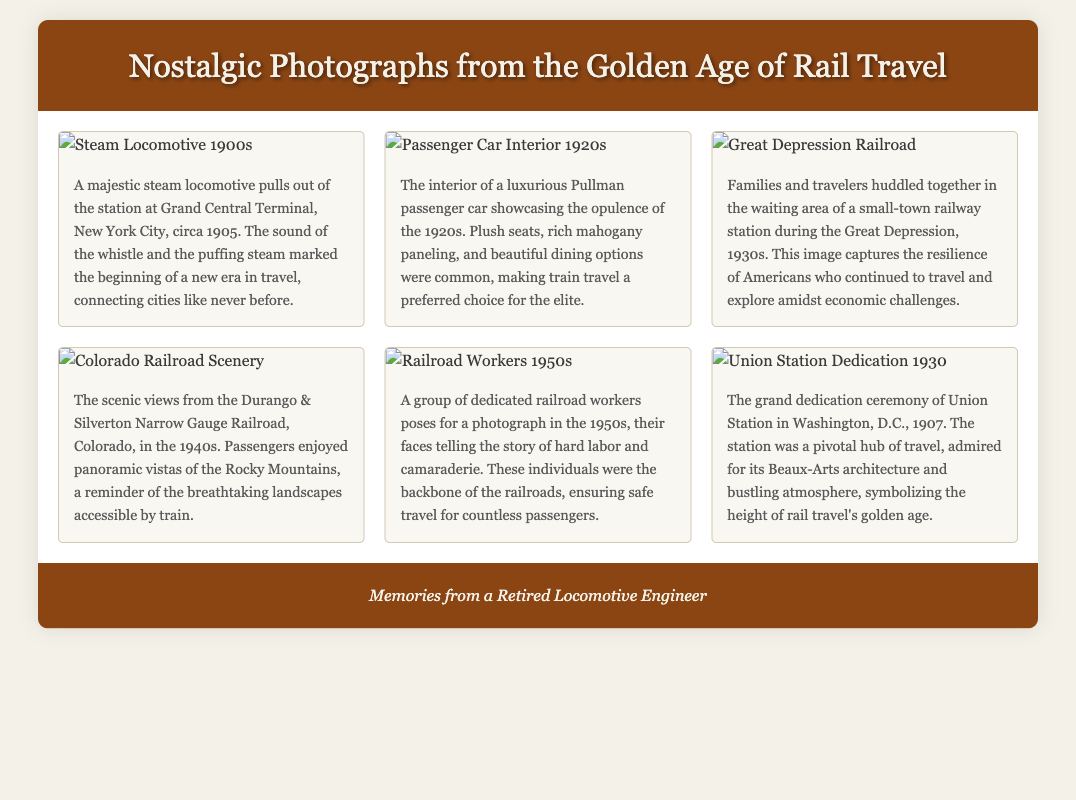What year was the steam locomotive photograph taken? The caption for the steam locomotive photograph specifies it was taken circa 1905.
Answer: 1905 What kind of passenger car is described in the 1920s photograph? The caption describes the passenger car as a luxurious Pullman passenger car.
Answer: Pullman What economic period is depicted in the photograph of the railway station? The caption mentions that the photograph shows a waiting area during the Great Depression.
Answer: Great Depression In which state did the Durango & Silverton Narrow Gauge Railroad operate? The caption notes that the scenic views were from Colorado.
Answer: Colorado What architectural style is mentioned regarding Union Station? The caption describes Union Station as being admired for its Beaux-Arts architecture.
Answer: Beaux-Arts What decade is represented by the photograph of railroad workers? The caption specifies that the photograph of railroad workers was taken in the 1950s.
Answer: 1950s What is emphasized about the railroad workers' role in the caption? The caption highlights that the railroad workers were the backbone of the railroads.
Answer: Backbone What was a key attraction of train travel according to the 1940s photograph? The caption mentions breathtaking landscapes were a key attraction of train travel.
Answer: Breathtaking landscapes 